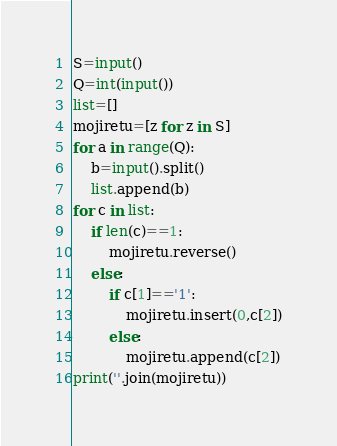Convert code to text. <code><loc_0><loc_0><loc_500><loc_500><_Python_>S=input()
Q=int(input())
list=[]
mojiretu=[z for z in S]
for a in range(Q):
    b=input().split()
    list.append(b)
for c in list:
    if len(c)==1:
        mojiretu.reverse()
    else:
        if c[1]=='1':
            mojiretu.insert(0,c[2])
        else:
            mojiretu.append(c[2])
print(''.join(mojiretu))
</code> 